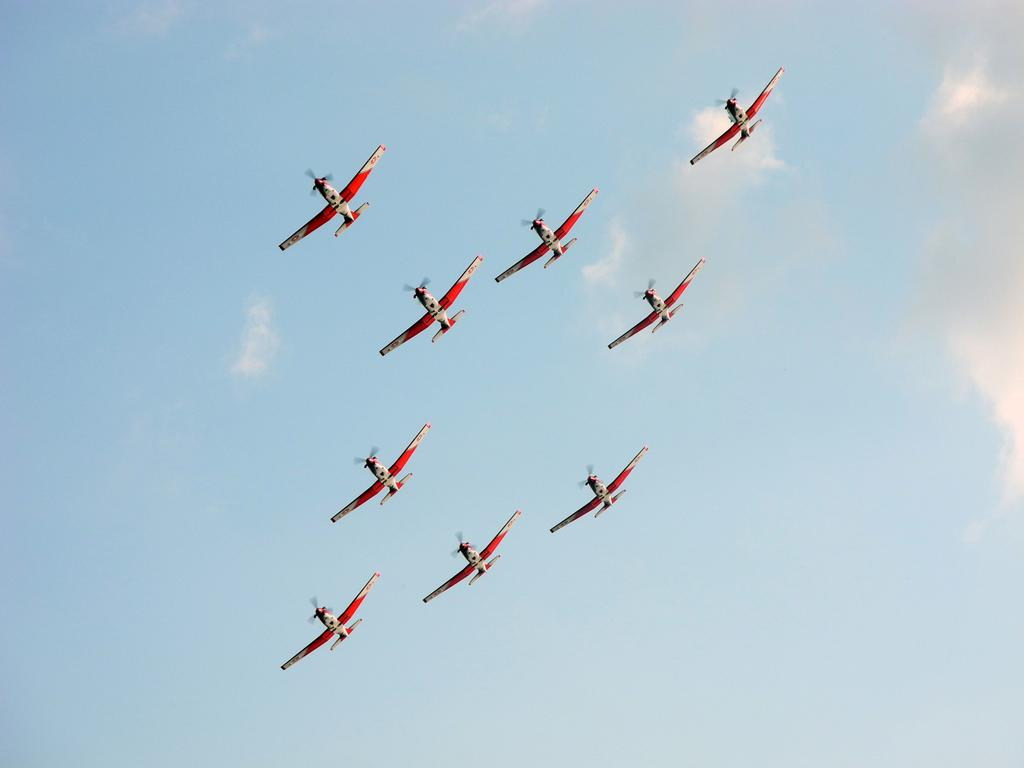What type of vehicles are present in the image? There are fleets of aircraft in the image. Where are the aircraft located? The aircraft are in the air. What can be seen in the background of the image? The sky is visible in the image. What time of day is the image likely taken? The image is likely taken during the day, as the sky is visible. What type of pipe is visible in the image? There is no pipe present in the image. How many sacks are being carried by the aircraft in the image? There are no sacks visible in the image, as it only features fleets of aircraft in the air. 